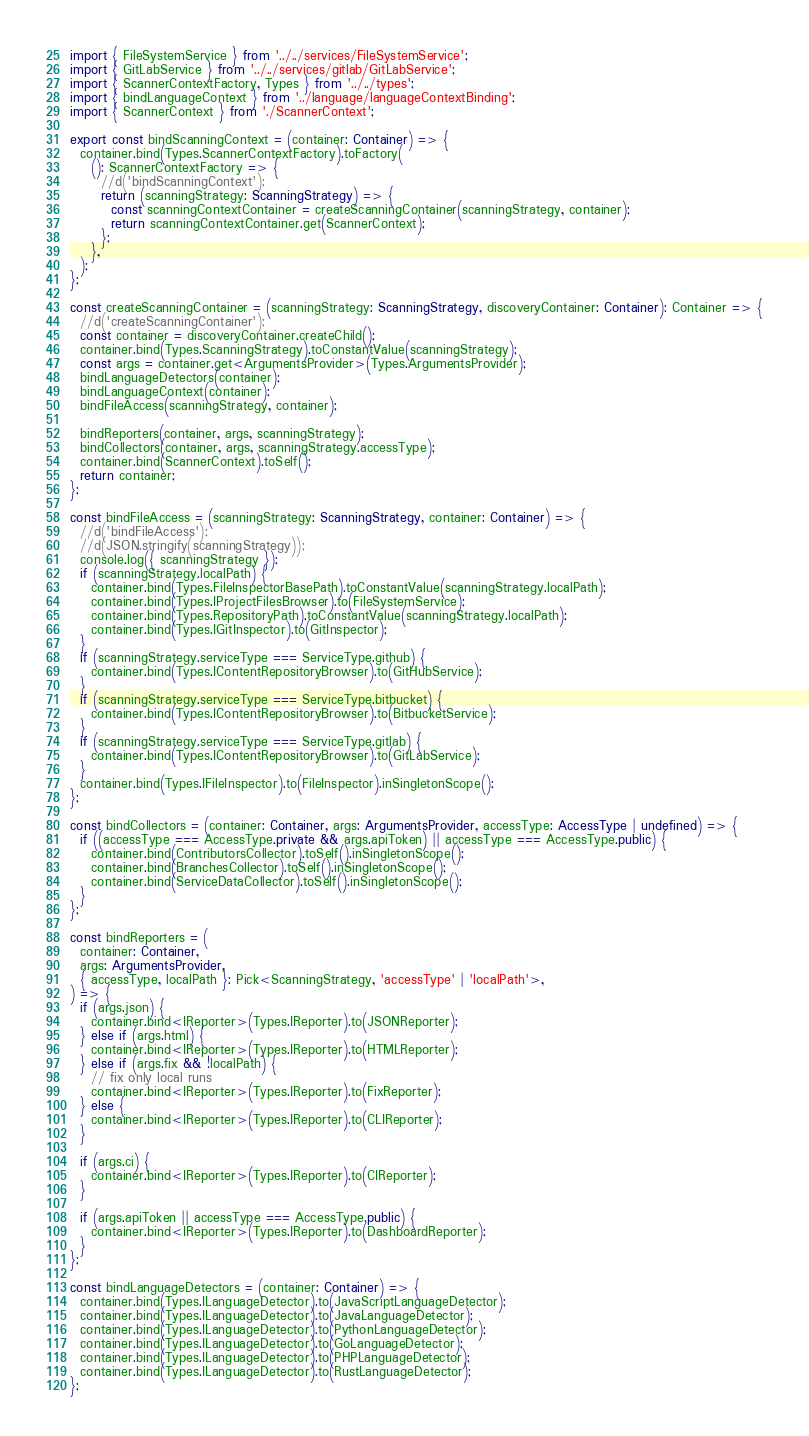<code> <loc_0><loc_0><loc_500><loc_500><_TypeScript_>import { FileSystemService } from '../../services/FileSystemService';
import { GitLabService } from '../../services/gitlab/GitLabService';
import { ScannerContextFactory, Types } from '../../types';
import { bindLanguageContext } from '../language/languageContextBinding';
import { ScannerContext } from './ScannerContext';

export const bindScanningContext = (container: Container) => {
  container.bind(Types.ScannerContextFactory).toFactory(
    (): ScannerContextFactory => {
      //d('bindScanningContext');
      return (scanningStrategy: ScanningStrategy) => {
        const scanningContextContainer = createScanningContainer(scanningStrategy, container);
        return scanningContextContainer.get(ScannerContext);
      };
    },
  );
};

const createScanningContainer = (scanningStrategy: ScanningStrategy, discoveryContainer: Container): Container => {
  //d('createScanningContainer');
  const container = discoveryContainer.createChild();
  container.bind(Types.ScanningStrategy).toConstantValue(scanningStrategy);
  const args = container.get<ArgumentsProvider>(Types.ArgumentsProvider);
  bindLanguageDetectors(container);
  bindLanguageContext(container);
  bindFileAccess(scanningStrategy, container);

  bindReporters(container, args, scanningStrategy);
  bindCollectors(container, args, scanningStrategy.accessType);
  container.bind(ScannerContext).toSelf();
  return container;
};

const bindFileAccess = (scanningStrategy: ScanningStrategy, container: Container) => {
  //d('bindFileAccess');
  //d(JSON.stringify(scanningStrategy));
  console.log({ scanningStrategy });
  if (scanningStrategy.localPath) {
    container.bind(Types.FileInspectorBasePath).toConstantValue(scanningStrategy.localPath);
    container.bind(Types.IProjectFilesBrowser).to(FileSystemService);
    container.bind(Types.RepositoryPath).toConstantValue(scanningStrategy.localPath);
    container.bind(Types.IGitInspector).to(GitInspector);
  }
  if (scanningStrategy.serviceType === ServiceType.github) {
    container.bind(Types.IContentRepositoryBrowser).to(GitHubService);
  }
  if (scanningStrategy.serviceType === ServiceType.bitbucket) {
    container.bind(Types.IContentRepositoryBrowser).to(BitbucketService);
  }
  if (scanningStrategy.serviceType === ServiceType.gitlab) {
    container.bind(Types.IContentRepositoryBrowser).to(GitLabService);
  }
  container.bind(Types.IFileInspector).to(FileInspector).inSingletonScope();
};

const bindCollectors = (container: Container, args: ArgumentsProvider, accessType: AccessType | undefined) => {
  if ((accessType === AccessType.private && args.apiToken) || accessType === AccessType.public) {
    container.bind(ContributorsCollector).toSelf().inSingletonScope();
    container.bind(BranchesCollector).toSelf().inSingletonScope();
    container.bind(ServiceDataCollector).toSelf().inSingletonScope();
  }
};

const bindReporters = (
  container: Container,
  args: ArgumentsProvider,
  { accessType, localPath }: Pick<ScanningStrategy, 'accessType' | 'localPath'>,
) => {
  if (args.json) {
    container.bind<IReporter>(Types.IReporter).to(JSONReporter);
  } else if (args.html) {
    container.bind<IReporter>(Types.IReporter).to(HTMLReporter);
  } else if (args.fix && !localPath) {
    // fix only local runs
    container.bind<IReporter>(Types.IReporter).to(FixReporter);
  } else {
    container.bind<IReporter>(Types.IReporter).to(CLIReporter);
  }

  if (args.ci) {
    container.bind<IReporter>(Types.IReporter).to(CIReporter);
  }

  if (args.apiToken || accessType === AccessType.public) {
    container.bind<IReporter>(Types.IReporter).to(DashboardReporter);
  }
};

const bindLanguageDetectors = (container: Container) => {
  container.bind(Types.ILanguageDetector).to(JavaScriptLanguageDetector);
  container.bind(Types.ILanguageDetector).to(JavaLanguageDetector);
  container.bind(Types.ILanguageDetector).to(PythonLanguageDetector);
  container.bind(Types.ILanguageDetector).to(GoLanguageDetector);
  container.bind(Types.ILanguageDetector).to(PHPLanguageDetector);
  container.bind(Types.ILanguageDetector).to(RustLanguageDetector);
};
</code> 